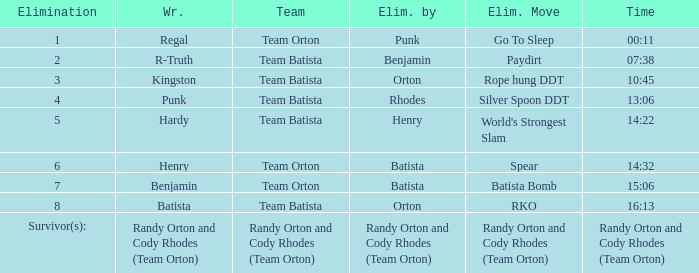What time was the Wrestler Henry eliminated by Batista? 14:32. 